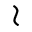<formula> <loc_0><loc_0><loc_500><loc_500>\wr</formula> 